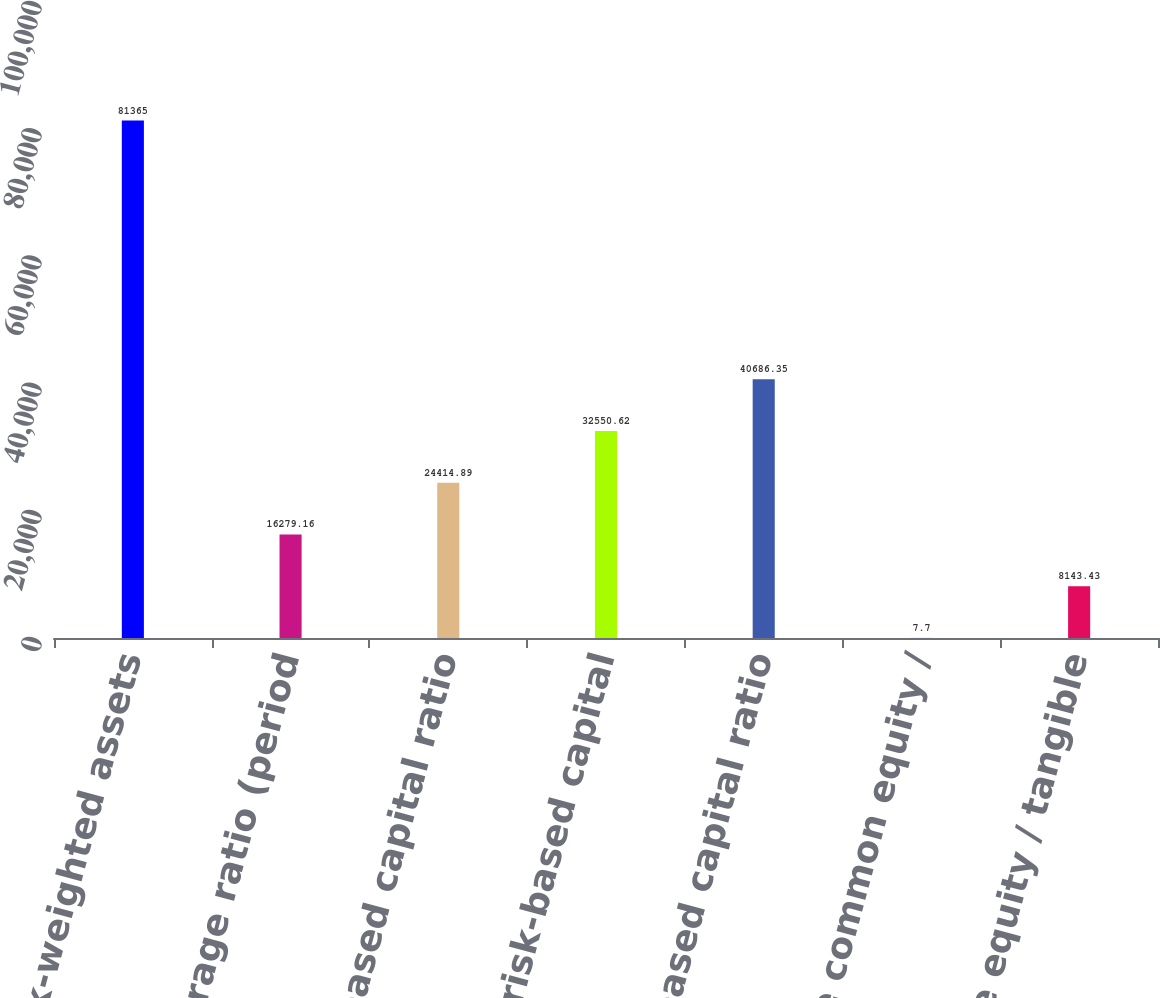<chart> <loc_0><loc_0><loc_500><loc_500><bar_chart><fcel>Total risk-weighted assets<fcel>Tier 1 leverage ratio (period<fcel>CET 1 risk-based capital ratio<fcel>Tier 1 risk-based capital<fcel>Total risk-based capital ratio<fcel>Tangible common equity /<fcel>Tangible equity / tangible<nl><fcel>81365<fcel>16279.2<fcel>24414.9<fcel>32550.6<fcel>40686.3<fcel>7.7<fcel>8143.43<nl></chart> 